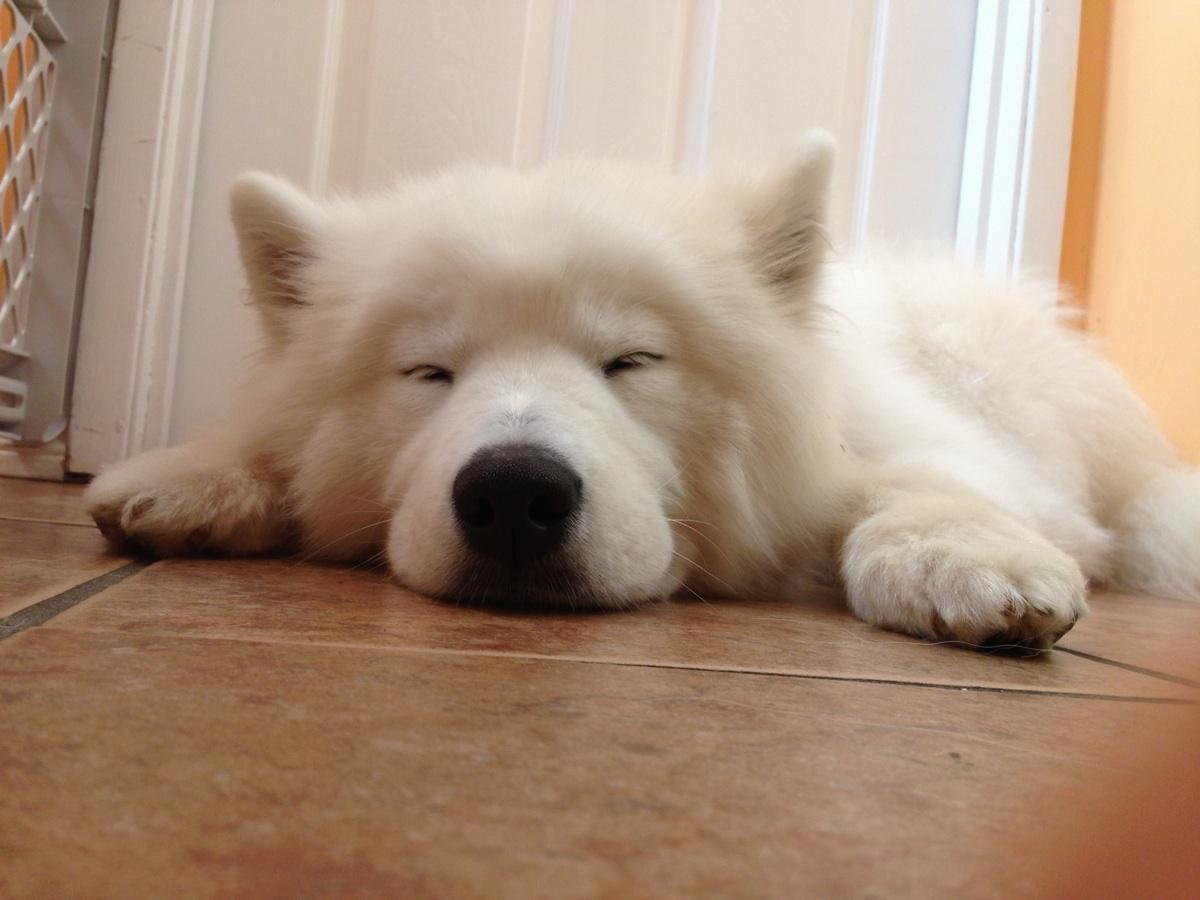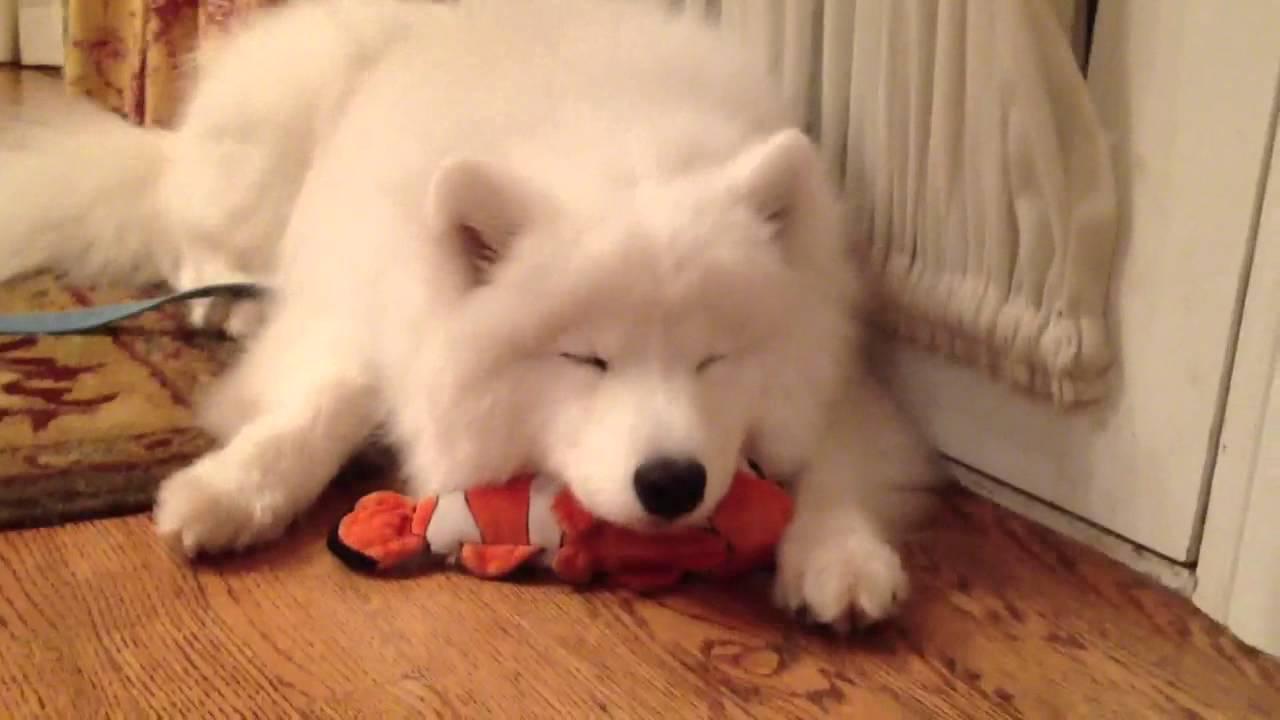The first image is the image on the left, the second image is the image on the right. Considering the images on both sides, is "One image shows a white dog sleeping on a hard tile floor." valid? Answer yes or no. Yes. The first image is the image on the left, the second image is the image on the right. Evaluate the accuracy of this statement regarding the images: "The dog in one of the images is sleeping on a wooden surface.". Is it true? Answer yes or no. Yes. 